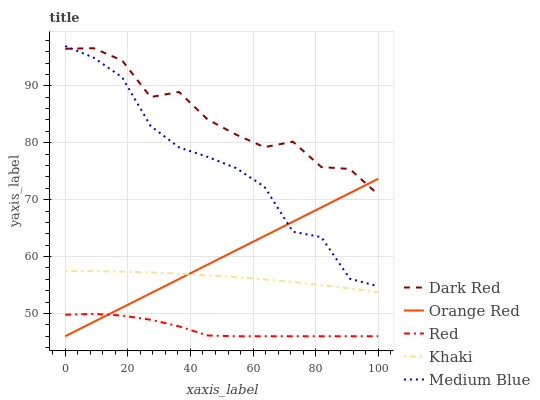Does Red have the minimum area under the curve?
Answer yes or no. Yes. Does Dark Red have the maximum area under the curve?
Answer yes or no. Yes. Does Khaki have the minimum area under the curve?
Answer yes or no. No. Does Khaki have the maximum area under the curve?
Answer yes or no. No. Is Orange Red the smoothest?
Answer yes or no. Yes. Is Dark Red the roughest?
Answer yes or no. Yes. Is Khaki the smoothest?
Answer yes or no. No. Is Khaki the roughest?
Answer yes or no. No. Does Khaki have the lowest value?
Answer yes or no. No. Does Medium Blue have the highest value?
Answer yes or no. Yes. Does Khaki have the highest value?
Answer yes or no. No. Is Khaki less than Dark Red?
Answer yes or no. Yes. Is Dark Red greater than Khaki?
Answer yes or no. Yes. Does Khaki intersect Dark Red?
Answer yes or no. No. 